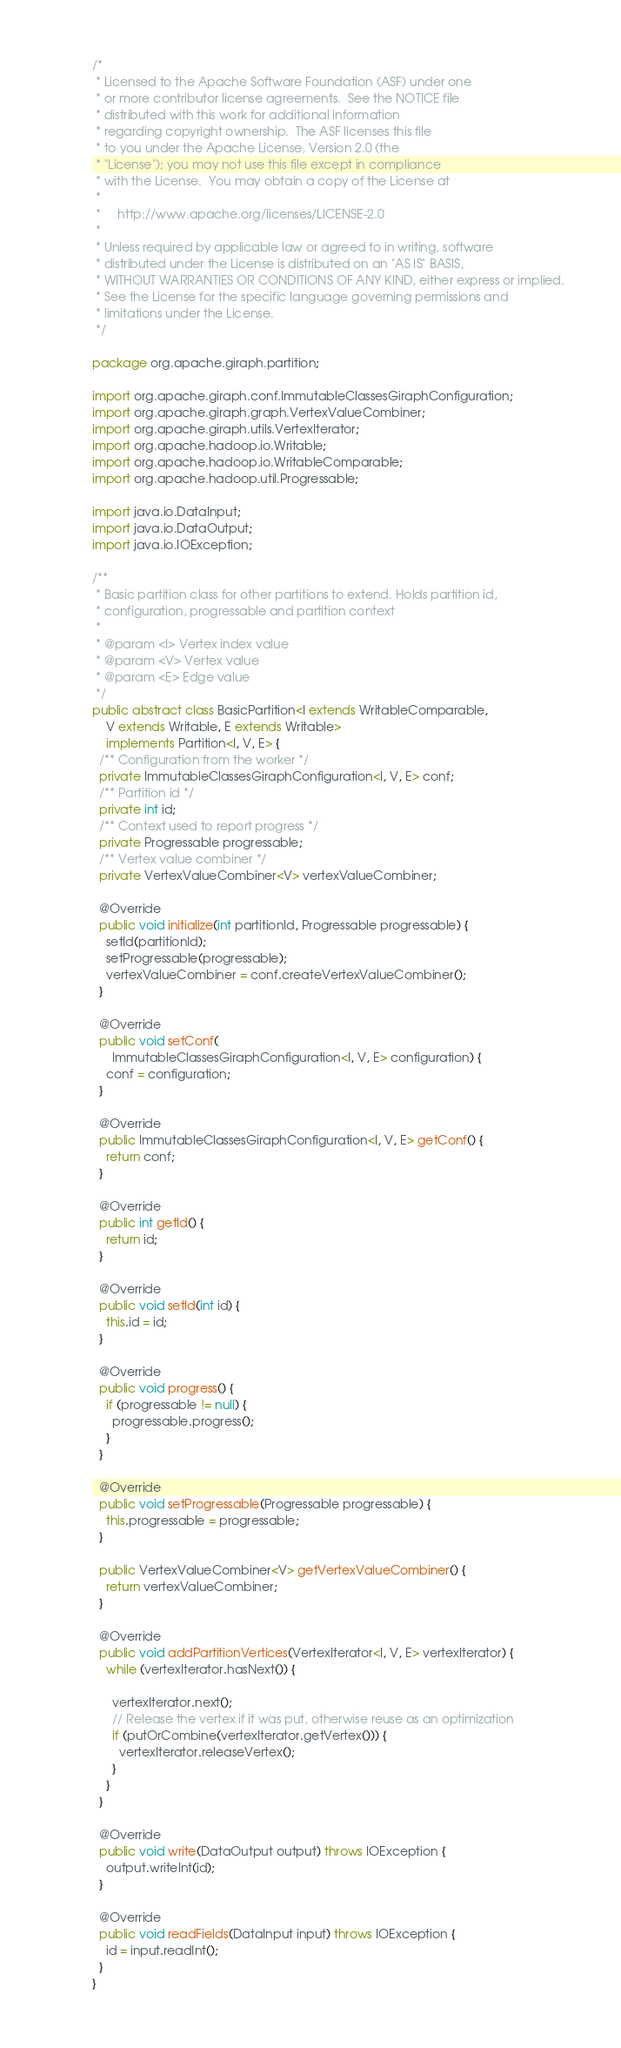Convert code to text. <code><loc_0><loc_0><loc_500><loc_500><_Java_>/*
 * Licensed to the Apache Software Foundation (ASF) under one
 * or more contributor license agreements.  See the NOTICE file
 * distributed with this work for additional information
 * regarding copyright ownership.  The ASF licenses this file
 * to you under the Apache License, Version 2.0 (the
 * "License"); you may not use this file except in compliance
 * with the License.  You may obtain a copy of the License at
 *
 *     http://www.apache.org/licenses/LICENSE-2.0
 *
 * Unless required by applicable law or agreed to in writing, software
 * distributed under the License is distributed on an "AS IS" BASIS,
 * WITHOUT WARRANTIES OR CONDITIONS OF ANY KIND, either express or implied.
 * See the License for the specific language governing permissions and
 * limitations under the License.
 */

package org.apache.giraph.partition;

import org.apache.giraph.conf.ImmutableClassesGiraphConfiguration;
import org.apache.giraph.graph.VertexValueCombiner;
import org.apache.giraph.utils.VertexIterator;
import org.apache.hadoop.io.Writable;
import org.apache.hadoop.io.WritableComparable;
import org.apache.hadoop.util.Progressable;

import java.io.DataInput;
import java.io.DataOutput;
import java.io.IOException;

/**
 * Basic partition class for other partitions to extend. Holds partition id,
 * configuration, progressable and partition context
 *
 * @param <I> Vertex index value
 * @param <V> Vertex value
 * @param <E> Edge value
 */
public abstract class BasicPartition<I extends WritableComparable,
    V extends Writable, E extends Writable>
    implements Partition<I, V, E> {
  /** Configuration from the worker */
  private ImmutableClassesGiraphConfiguration<I, V, E> conf;
  /** Partition id */
  private int id;
  /** Context used to report progress */
  private Progressable progressable;
  /** Vertex value combiner */
  private VertexValueCombiner<V> vertexValueCombiner;

  @Override
  public void initialize(int partitionId, Progressable progressable) {
    setId(partitionId);
    setProgressable(progressable);
    vertexValueCombiner = conf.createVertexValueCombiner();
  }

  @Override
  public void setConf(
      ImmutableClassesGiraphConfiguration<I, V, E> configuration) {
    conf = configuration;
  }

  @Override
  public ImmutableClassesGiraphConfiguration<I, V, E> getConf() {
    return conf;
  }

  @Override
  public int getId() {
    return id;
  }

  @Override
  public void setId(int id) {
    this.id = id;
  }

  @Override
  public void progress() {
    if (progressable != null) {
      progressable.progress();
    }
  }

  @Override
  public void setProgressable(Progressable progressable) {
    this.progressable = progressable;
  }

  public VertexValueCombiner<V> getVertexValueCombiner() {
    return vertexValueCombiner;
  }

  @Override
  public void addPartitionVertices(VertexIterator<I, V, E> vertexIterator) {
    while (vertexIterator.hasNext()) {

      vertexIterator.next();
      // Release the vertex if it was put, otherwise reuse as an optimization
      if (putOrCombine(vertexIterator.getVertex())) {
        vertexIterator.releaseVertex();
      }
    }
  }

  @Override
  public void write(DataOutput output) throws IOException {
    output.writeInt(id);
  }

  @Override
  public void readFields(DataInput input) throws IOException {
    id = input.readInt();
  }
}
</code> 